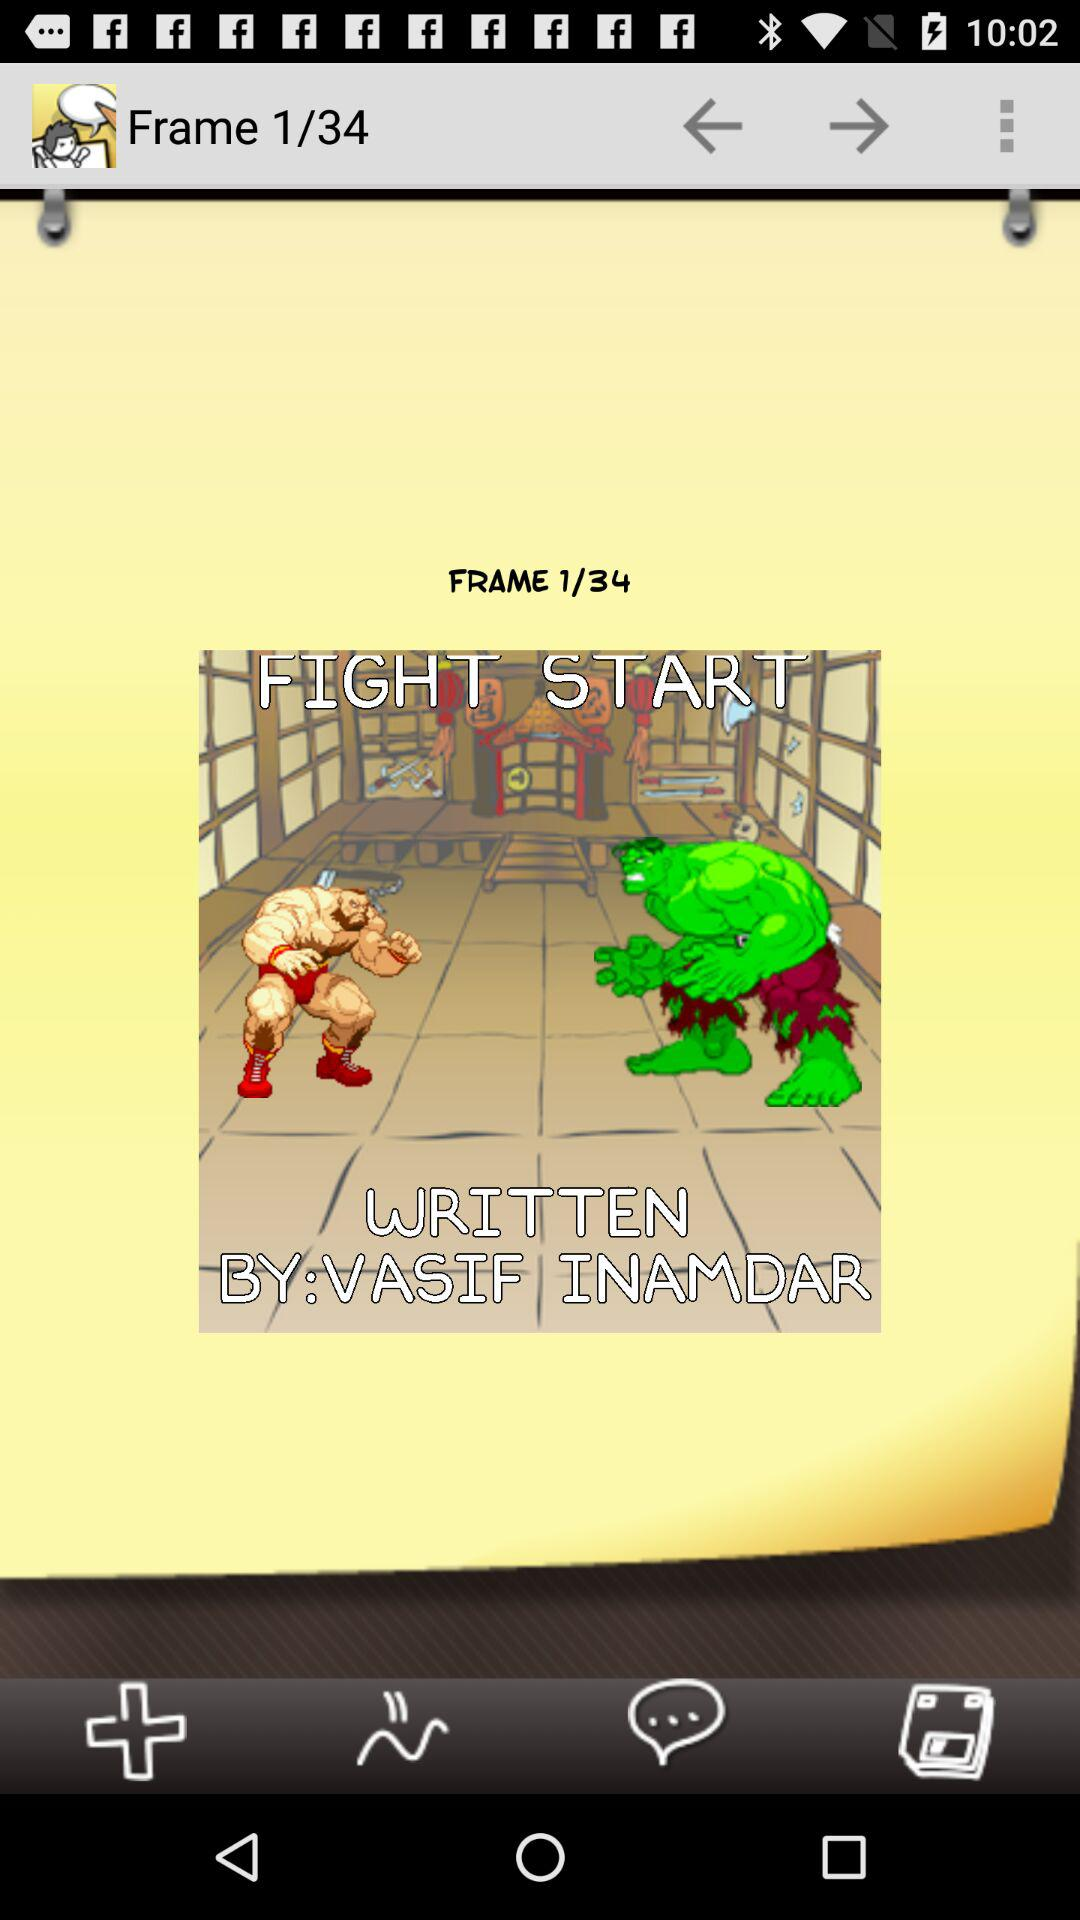What is the total number of frames? The total number of frames is 34. 